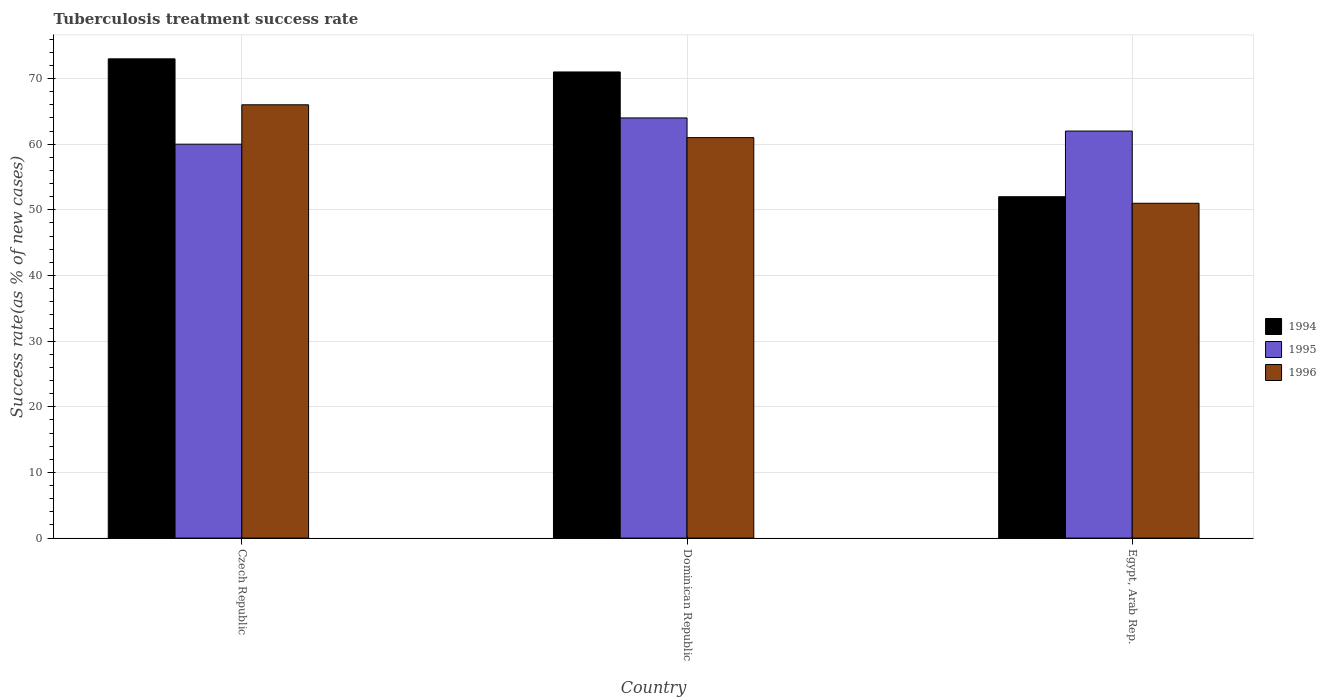How many different coloured bars are there?
Keep it short and to the point. 3. How many bars are there on the 2nd tick from the left?
Your answer should be very brief. 3. What is the label of the 2nd group of bars from the left?
Give a very brief answer. Dominican Republic. In how many cases, is the number of bars for a given country not equal to the number of legend labels?
Your response must be concise. 0. What is the tuberculosis treatment success rate in 1995 in Egypt, Arab Rep.?
Give a very brief answer. 62. Across all countries, what is the minimum tuberculosis treatment success rate in 1996?
Your answer should be very brief. 51. In which country was the tuberculosis treatment success rate in 1996 maximum?
Provide a succinct answer. Czech Republic. In which country was the tuberculosis treatment success rate in 1996 minimum?
Make the answer very short. Egypt, Arab Rep. What is the total tuberculosis treatment success rate in 1996 in the graph?
Make the answer very short. 178. What is the difference between the tuberculosis treatment success rate in 1996 in Czech Republic and that in Egypt, Arab Rep.?
Keep it short and to the point. 15. What is the average tuberculosis treatment success rate in 1995 per country?
Make the answer very short. 62. What is the difference between the tuberculosis treatment success rate of/in 1994 and tuberculosis treatment success rate of/in 1995 in Egypt, Arab Rep.?
Your response must be concise. -10. In how many countries, is the tuberculosis treatment success rate in 1994 greater than 44 %?
Your answer should be very brief. 3. What is the ratio of the tuberculosis treatment success rate in 1995 in Czech Republic to that in Dominican Republic?
Offer a very short reply. 0.94. Is the difference between the tuberculosis treatment success rate in 1994 in Czech Republic and Dominican Republic greater than the difference between the tuberculosis treatment success rate in 1995 in Czech Republic and Dominican Republic?
Your answer should be very brief. Yes. What is the difference between the highest and the lowest tuberculosis treatment success rate in 1996?
Your response must be concise. 15. In how many countries, is the tuberculosis treatment success rate in 1996 greater than the average tuberculosis treatment success rate in 1996 taken over all countries?
Give a very brief answer. 2. What does the 1st bar from the left in Egypt, Arab Rep. represents?
Ensure brevity in your answer.  1994. What does the 1st bar from the right in Egypt, Arab Rep. represents?
Ensure brevity in your answer.  1996. Are all the bars in the graph horizontal?
Provide a short and direct response. No. How many countries are there in the graph?
Your answer should be very brief. 3. Are the values on the major ticks of Y-axis written in scientific E-notation?
Provide a succinct answer. No. Does the graph contain any zero values?
Ensure brevity in your answer.  No. Does the graph contain grids?
Ensure brevity in your answer.  Yes. What is the title of the graph?
Your answer should be compact. Tuberculosis treatment success rate. Does "1968" appear as one of the legend labels in the graph?
Offer a very short reply. No. What is the label or title of the Y-axis?
Your response must be concise. Success rate(as % of new cases). What is the Success rate(as % of new cases) of 1996 in Czech Republic?
Ensure brevity in your answer.  66. What is the Success rate(as % of new cases) of 1994 in Dominican Republic?
Your answer should be compact. 71. What is the Success rate(as % of new cases) in 1995 in Egypt, Arab Rep.?
Your response must be concise. 62. What is the Success rate(as % of new cases) in 1996 in Egypt, Arab Rep.?
Your answer should be compact. 51. Across all countries, what is the maximum Success rate(as % of new cases) of 1995?
Offer a very short reply. 64. Across all countries, what is the minimum Success rate(as % of new cases) of 1996?
Offer a terse response. 51. What is the total Success rate(as % of new cases) of 1994 in the graph?
Your response must be concise. 196. What is the total Success rate(as % of new cases) in 1995 in the graph?
Offer a very short reply. 186. What is the total Success rate(as % of new cases) of 1996 in the graph?
Provide a short and direct response. 178. What is the difference between the Success rate(as % of new cases) in 1996 in Czech Republic and that in Dominican Republic?
Your response must be concise. 5. What is the difference between the Success rate(as % of new cases) in 1994 in Czech Republic and that in Egypt, Arab Rep.?
Your answer should be very brief. 21. What is the difference between the Success rate(as % of new cases) of 1995 in Czech Republic and that in Egypt, Arab Rep.?
Ensure brevity in your answer.  -2. What is the difference between the Success rate(as % of new cases) of 1994 in Dominican Republic and that in Egypt, Arab Rep.?
Give a very brief answer. 19. What is the difference between the Success rate(as % of new cases) of 1996 in Dominican Republic and that in Egypt, Arab Rep.?
Your response must be concise. 10. What is the difference between the Success rate(as % of new cases) of 1994 in Dominican Republic and the Success rate(as % of new cases) of 1995 in Egypt, Arab Rep.?
Your answer should be very brief. 9. What is the difference between the Success rate(as % of new cases) of 1994 in Dominican Republic and the Success rate(as % of new cases) of 1996 in Egypt, Arab Rep.?
Ensure brevity in your answer.  20. What is the average Success rate(as % of new cases) of 1994 per country?
Keep it short and to the point. 65.33. What is the average Success rate(as % of new cases) of 1996 per country?
Provide a succinct answer. 59.33. What is the difference between the Success rate(as % of new cases) in 1994 and Success rate(as % of new cases) in 1995 in Czech Republic?
Offer a very short reply. 13. What is the difference between the Success rate(as % of new cases) in 1995 and Success rate(as % of new cases) in 1996 in Czech Republic?
Offer a terse response. -6. What is the difference between the Success rate(as % of new cases) in 1994 and Success rate(as % of new cases) in 1995 in Dominican Republic?
Keep it short and to the point. 7. What is the difference between the Success rate(as % of new cases) of 1994 and Success rate(as % of new cases) of 1996 in Egypt, Arab Rep.?
Make the answer very short. 1. What is the ratio of the Success rate(as % of new cases) of 1994 in Czech Republic to that in Dominican Republic?
Offer a very short reply. 1.03. What is the ratio of the Success rate(as % of new cases) of 1996 in Czech Republic to that in Dominican Republic?
Offer a terse response. 1.08. What is the ratio of the Success rate(as % of new cases) of 1994 in Czech Republic to that in Egypt, Arab Rep.?
Your answer should be very brief. 1.4. What is the ratio of the Success rate(as % of new cases) in 1996 in Czech Republic to that in Egypt, Arab Rep.?
Offer a terse response. 1.29. What is the ratio of the Success rate(as % of new cases) in 1994 in Dominican Republic to that in Egypt, Arab Rep.?
Your response must be concise. 1.37. What is the ratio of the Success rate(as % of new cases) in 1995 in Dominican Republic to that in Egypt, Arab Rep.?
Provide a succinct answer. 1.03. What is the ratio of the Success rate(as % of new cases) in 1996 in Dominican Republic to that in Egypt, Arab Rep.?
Your response must be concise. 1.2. What is the difference between the highest and the second highest Success rate(as % of new cases) of 1994?
Provide a succinct answer. 2. What is the difference between the highest and the second highest Success rate(as % of new cases) of 1996?
Offer a very short reply. 5. What is the difference between the highest and the lowest Success rate(as % of new cases) of 1995?
Your response must be concise. 4. What is the difference between the highest and the lowest Success rate(as % of new cases) of 1996?
Offer a terse response. 15. 